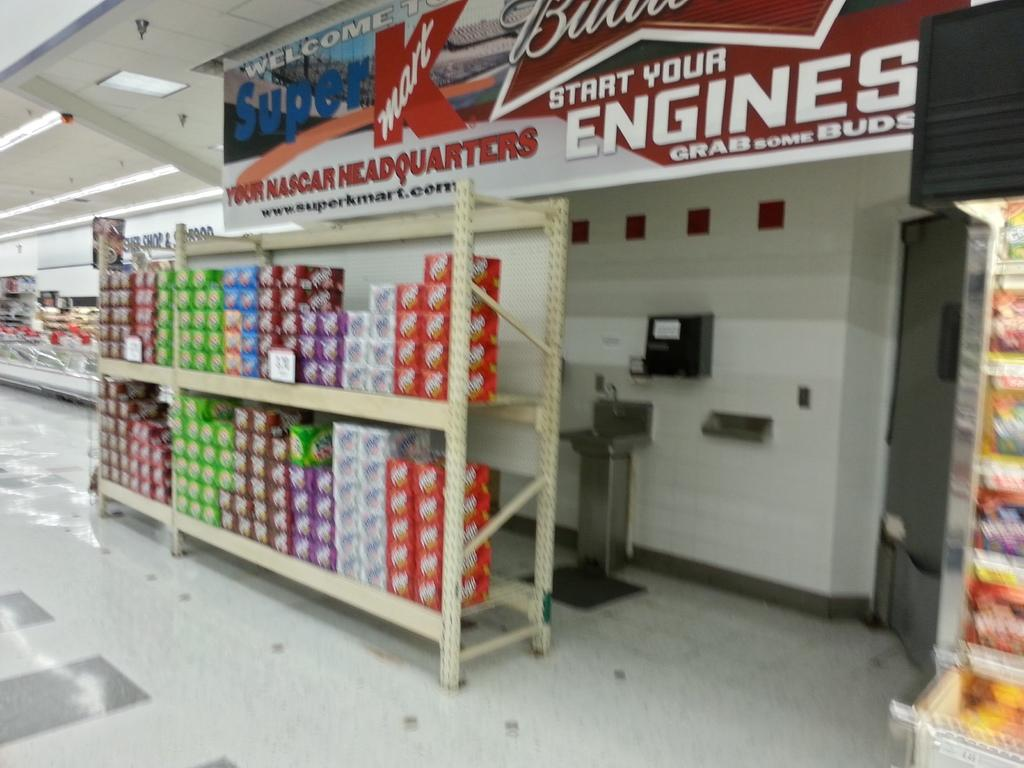Provide a one-sentence caption for the provided image. A kmart banner that says your Nascar headquarters is about 12pk cartons of various sodas. 